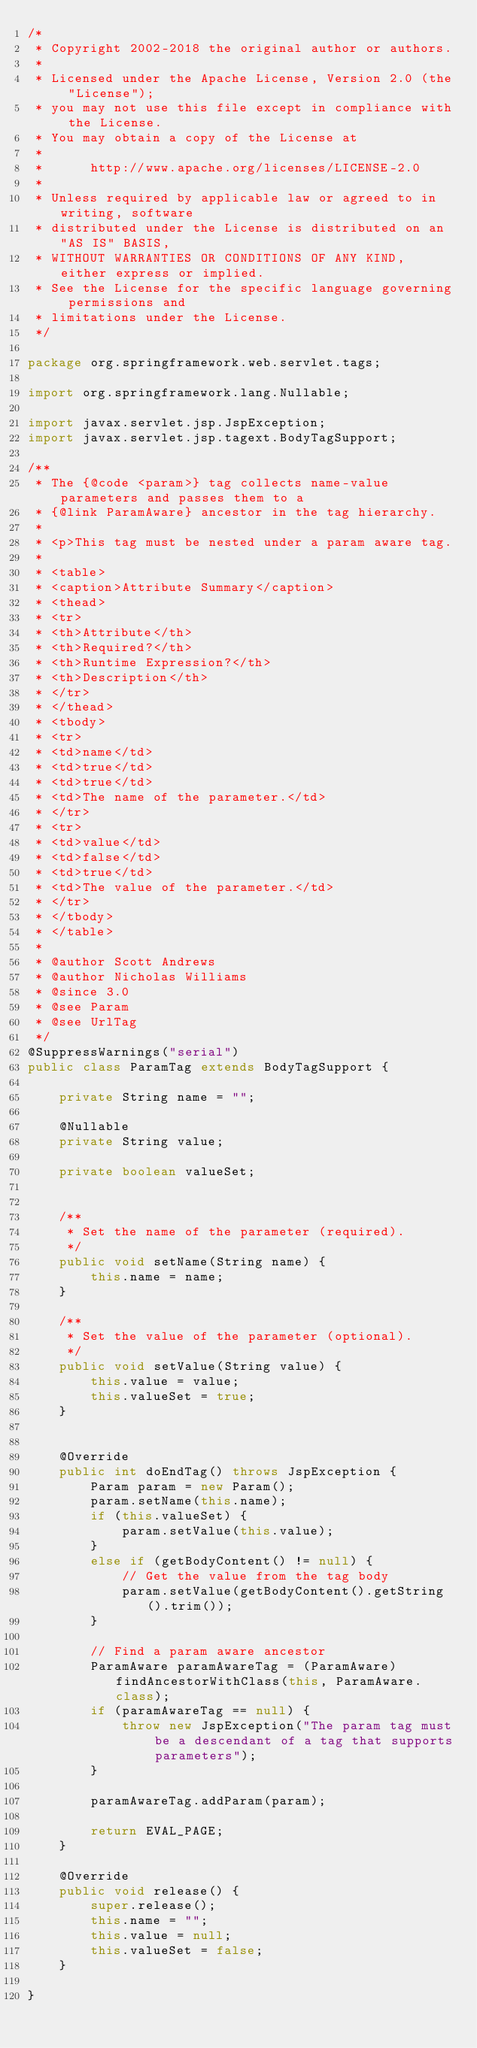<code> <loc_0><loc_0><loc_500><loc_500><_Java_>/*
 * Copyright 2002-2018 the original author or authors.
 *
 * Licensed under the Apache License, Version 2.0 (the "License");
 * you may not use this file except in compliance with the License.
 * You may obtain a copy of the License at
 *
 *      http://www.apache.org/licenses/LICENSE-2.0
 *
 * Unless required by applicable law or agreed to in writing, software
 * distributed under the License is distributed on an "AS IS" BASIS,
 * WITHOUT WARRANTIES OR CONDITIONS OF ANY KIND, either express or implied.
 * See the License for the specific language governing permissions and
 * limitations under the License.
 */

package org.springframework.web.servlet.tags;

import org.springframework.lang.Nullable;

import javax.servlet.jsp.JspException;
import javax.servlet.jsp.tagext.BodyTagSupport;

/**
 * The {@code <param>} tag collects name-value parameters and passes them to a
 * {@link ParamAware} ancestor in the tag hierarchy.
 *
 * <p>This tag must be nested under a param aware tag.
 *
 * <table>
 * <caption>Attribute Summary</caption>
 * <thead>
 * <tr>
 * <th>Attribute</th>
 * <th>Required?</th>
 * <th>Runtime Expression?</th>
 * <th>Description</th>
 * </tr>
 * </thead>
 * <tbody>
 * <tr>
 * <td>name</td>
 * <td>true</td>
 * <td>true</td>
 * <td>The name of the parameter.</td>
 * </tr>
 * <tr>
 * <td>value</td>
 * <td>false</td>
 * <td>true</td>
 * <td>The value of the parameter.</td>
 * </tr>
 * </tbody>
 * </table>
 *
 * @author Scott Andrews
 * @author Nicholas Williams
 * @since 3.0
 * @see Param
 * @see UrlTag
 */
@SuppressWarnings("serial")
public class ParamTag extends BodyTagSupport {

	private String name = "";

	@Nullable
	private String value;

	private boolean valueSet;


	/**
	 * Set the name of the parameter (required).
	 */
	public void setName(String name) {
		this.name = name;
	}

	/**
	 * Set the value of the parameter (optional).
	 */
	public void setValue(String value) {
		this.value = value;
		this.valueSet = true;
	}


	@Override
	public int doEndTag() throws JspException {
		Param param = new Param();
		param.setName(this.name);
		if (this.valueSet) {
			param.setValue(this.value);
		}
		else if (getBodyContent() != null) {
			// Get the value from the tag body
			param.setValue(getBodyContent().getString().trim());
		}

		// Find a param aware ancestor
		ParamAware paramAwareTag = (ParamAware) findAncestorWithClass(this, ParamAware.class);
		if (paramAwareTag == null) {
			throw new JspException("The param tag must be a descendant of a tag that supports parameters");
		}

		paramAwareTag.addParam(param);

		return EVAL_PAGE;
	}

	@Override
	public void release() {
		super.release();
		this.name = "";
		this.value = null;
		this.valueSet = false;
	}

}
</code> 